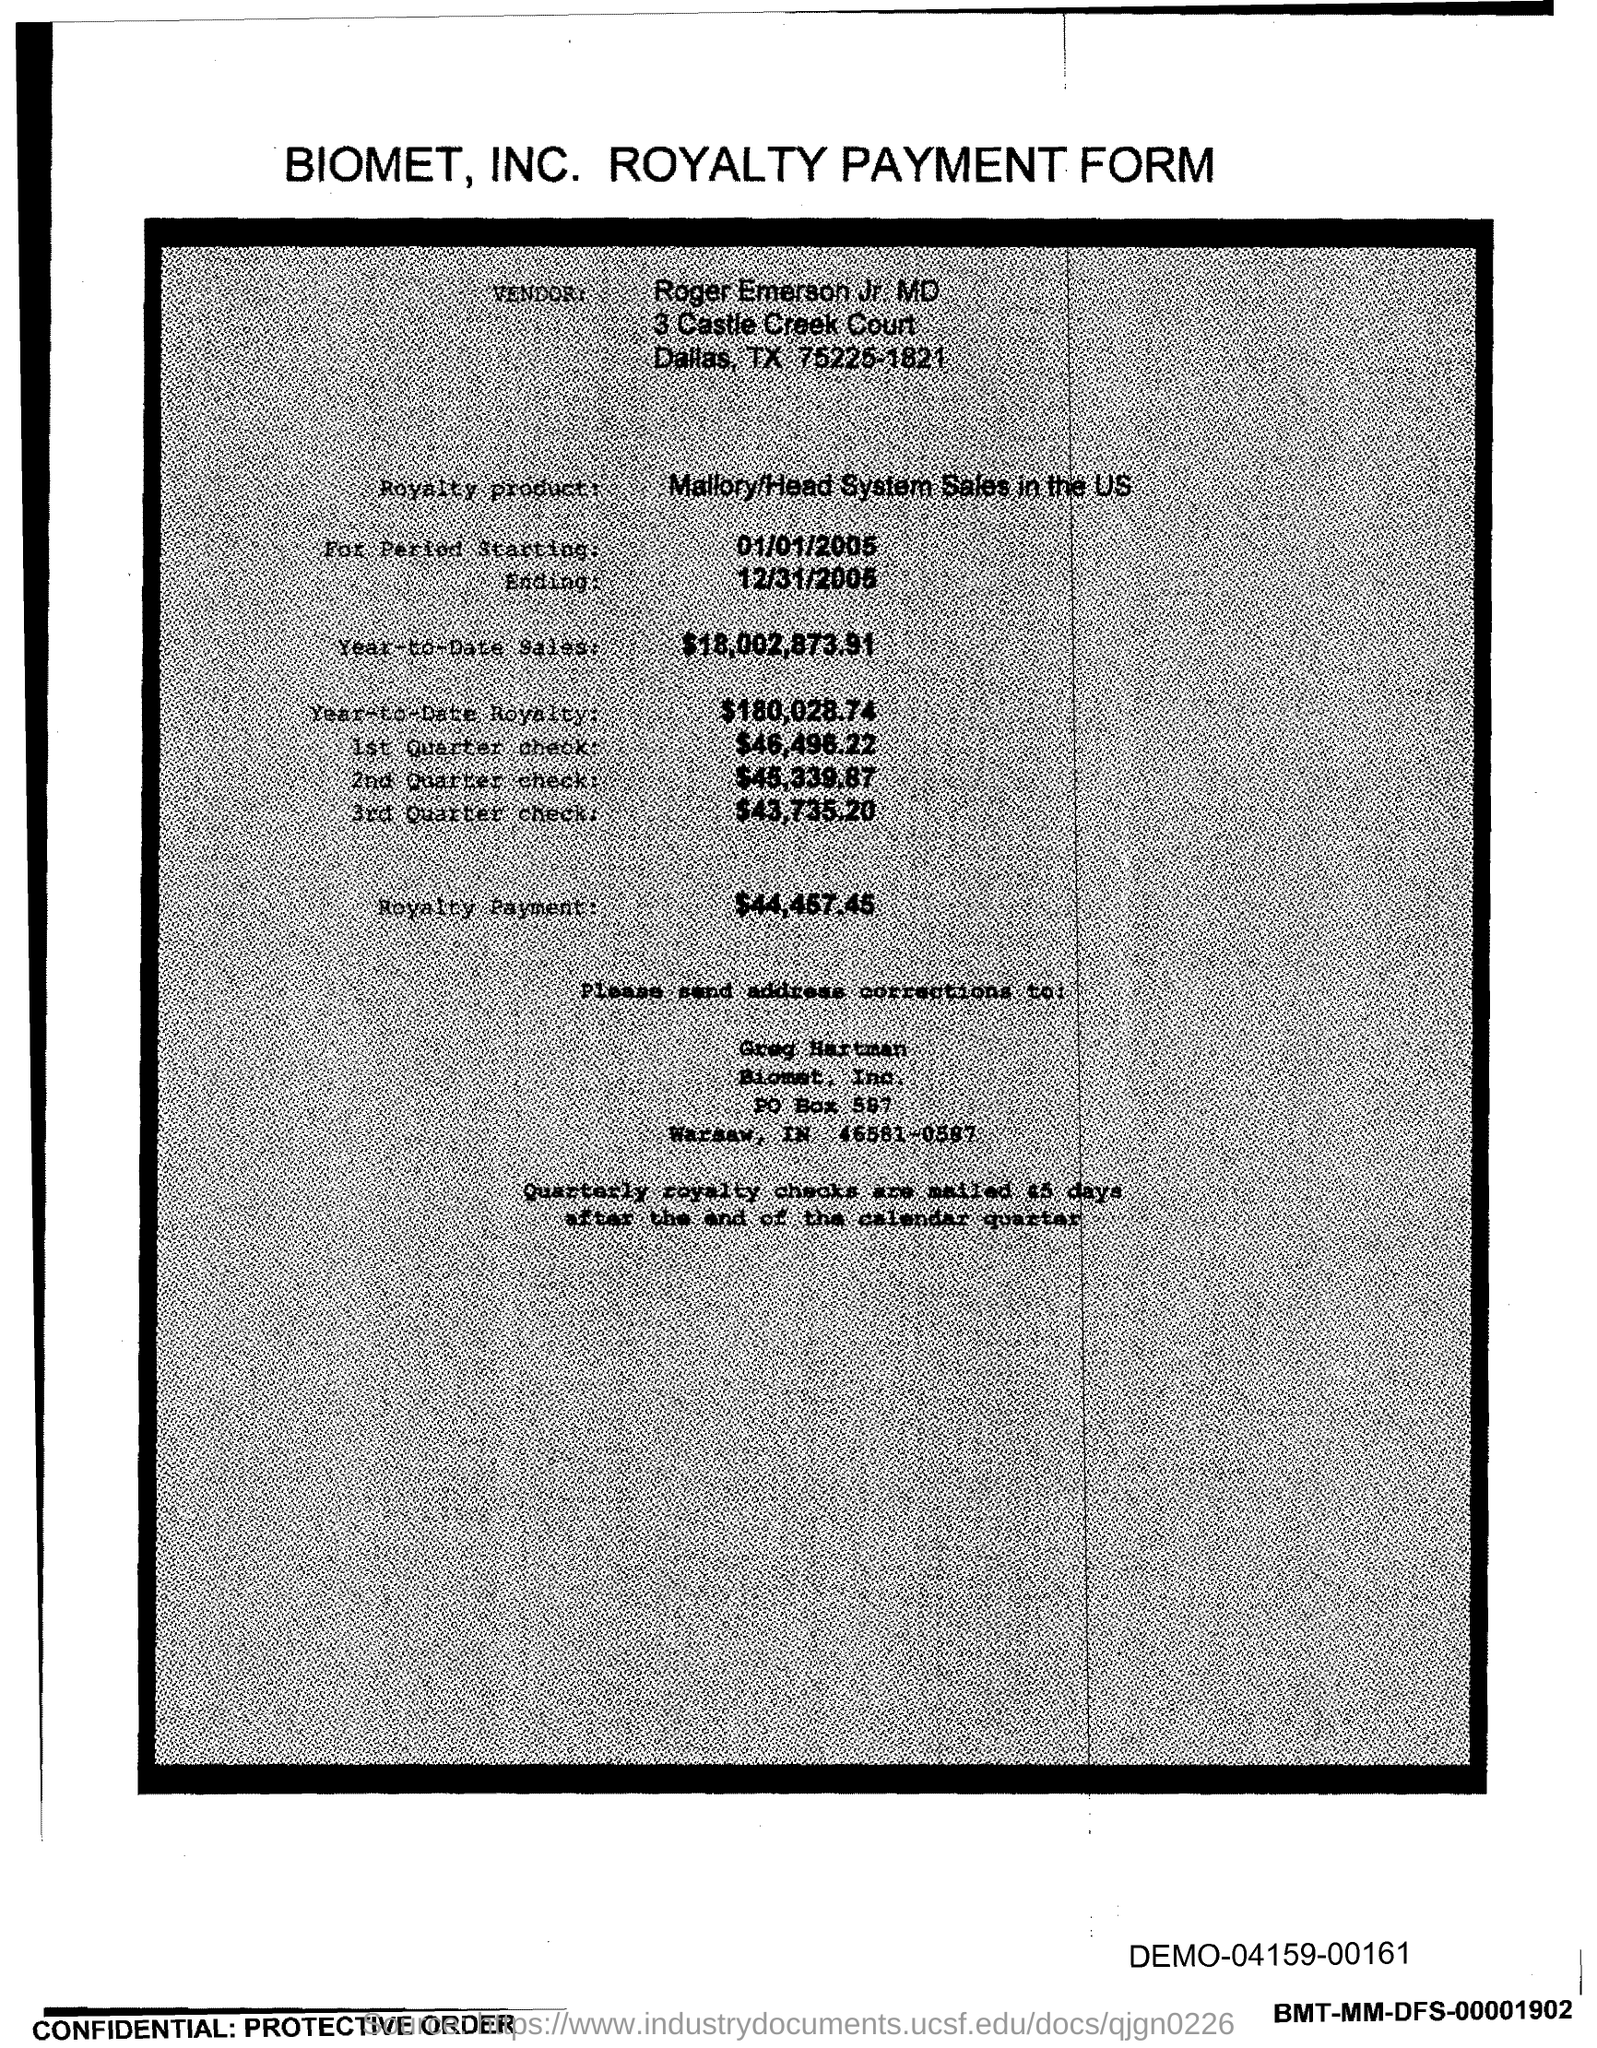What is the vendor name given in the form?
Make the answer very short. Roger Emerson Jr. MD. What is the royalty product given in the form?
Offer a very short reply. Mallory/Head System Sales in the US. What is the Year-to-Date Sales of the royalty product?
Provide a short and direct response. $18,002,873.91. What is the start date of the royalty period?
Ensure brevity in your answer.  01/01/2005. What is the amount of 1st quarter check mentioned in the form?
Your answer should be compact. $46,496.22. What is the Year-to-Date royalty of the product?
Ensure brevity in your answer.  $180,028.74. What is the amount of 3rd Quarter check given in the form?
Your response must be concise. $43,735.20. What is the end date of the royalty period?
Ensure brevity in your answer.  12/31/2005. 